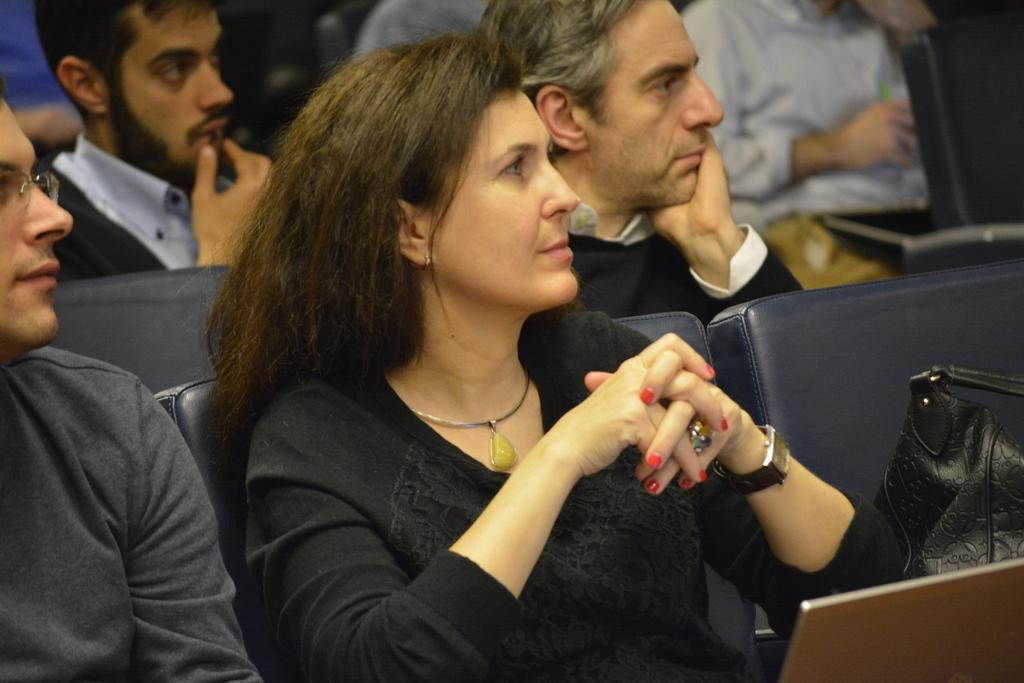How many persons are visible in the image? There are persons in the image, but the exact number cannot be determined from the provided facts. What type of furniture is present in the image? There are chairs in the image. What other objects can be seen in the image besides the persons and chairs? There are other objects in the image, but their specific nature cannot be determined from the provided facts. How many eggs are visible in the image? There are no eggs present in the image. 